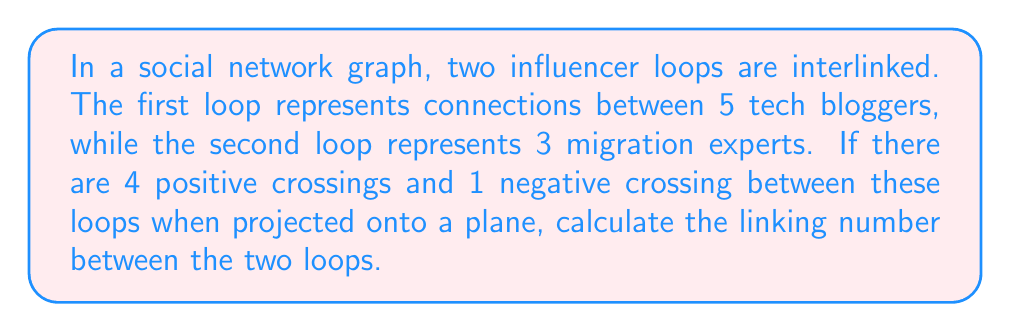Can you solve this math problem? To calculate the linking number between two interlinked loops in a social network graph, we follow these steps:

1. Identify the crossings: In this case, we have 4 positive crossings and 1 negative crossing.

2. Assign values to crossings:
   - Positive crossings: +1
   - Negative crossings: -1

3. Sum up the crossing values:
   $$(4 \times (+1)) + (1 \times (-1)) = 4 - 1 = 3$$

4. Calculate the linking number:
   The linking number is defined as half the sum of the crossing values.
   
   $$\text{Linking Number} = \frac{1}{2} \sum \text{(Crossing Values)}$$
   
   $$\text{Linking Number} = \frac{1}{2} \times 3 = \frac{3}{2}$$

The linking number $\frac{3}{2}$ indicates that the two loops in the social network graph are non-trivially linked and cannot be separated without breaking one of the loops.
Answer: $\frac{3}{2}$ 